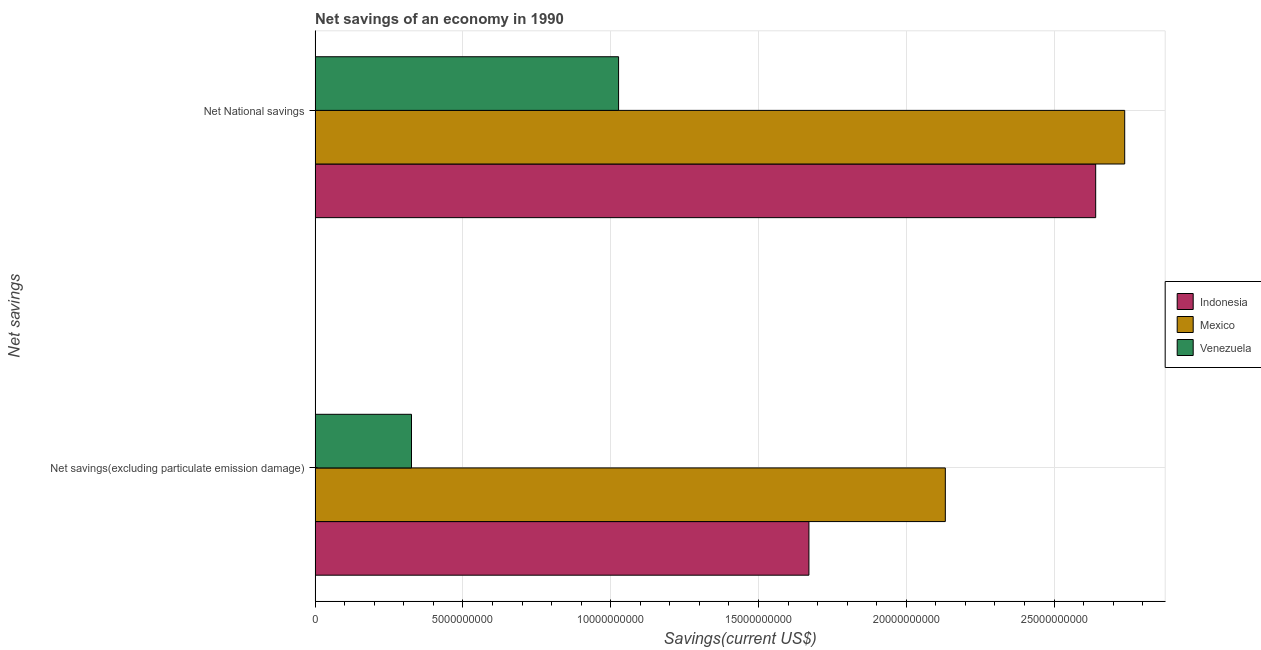How many bars are there on the 2nd tick from the top?
Offer a very short reply. 3. What is the label of the 2nd group of bars from the top?
Provide a short and direct response. Net savings(excluding particulate emission damage). What is the net savings(excluding particulate emission damage) in Mexico?
Provide a succinct answer. 2.13e+1. Across all countries, what is the maximum net national savings?
Your response must be concise. 2.74e+1. Across all countries, what is the minimum net national savings?
Provide a short and direct response. 1.03e+1. In which country was the net national savings maximum?
Your response must be concise. Mexico. In which country was the net savings(excluding particulate emission damage) minimum?
Provide a short and direct response. Venezuela. What is the total net national savings in the graph?
Offer a very short reply. 6.41e+1. What is the difference between the net savings(excluding particulate emission damage) in Venezuela and that in Indonesia?
Offer a terse response. -1.34e+1. What is the difference between the net national savings in Venezuela and the net savings(excluding particulate emission damage) in Mexico?
Your response must be concise. -1.11e+1. What is the average net national savings per country?
Offer a very short reply. 2.14e+1. What is the difference between the net savings(excluding particulate emission damage) and net national savings in Mexico?
Give a very brief answer. -6.07e+09. In how many countries, is the net national savings greater than 22000000000 US$?
Your answer should be compact. 2. What is the ratio of the net savings(excluding particulate emission damage) in Venezuela to that in Mexico?
Your answer should be compact. 0.15. Is the net savings(excluding particulate emission damage) in Mexico less than that in Venezuela?
Your answer should be compact. No. In how many countries, is the net savings(excluding particulate emission damage) greater than the average net savings(excluding particulate emission damage) taken over all countries?
Your answer should be very brief. 2. What does the 3rd bar from the bottom in Net savings(excluding particulate emission damage) represents?
Make the answer very short. Venezuela. How many bars are there?
Provide a short and direct response. 6. How many countries are there in the graph?
Give a very brief answer. 3. Where does the legend appear in the graph?
Your answer should be compact. Center right. What is the title of the graph?
Keep it short and to the point. Net savings of an economy in 1990. What is the label or title of the X-axis?
Provide a succinct answer. Savings(current US$). What is the label or title of the Y-axis?
Your answer should be compact. Net savings. What is the Savings(current US$) in Indonesia in Net savings(excluding particulate emission damage)?
Your response must be concise. 1.67e+1. What is the Savings(current US$) in Mexico in Net savings(excluding particulate emission damage)?
Your response must be concise. 2.13e+1. What is the Savings(current US$) of Venezuela in Net savings(excluding particulate emission damage)?
Give a very brief answer. 3.26e+09. What is the Savings(current US$) of Indonesia in Net National savings?
Give a very brief answer. 2.64e+1. What is the Savings(current US$) in Mexico in Net National savings?
Give a very brief answer. 2.74e+1. What is the Savings(current US$) of Venezuela in Net National savings?
Offer a very short reply. 1.03e+1. Across all Net savings, what is the maximum Savings(current US$) in Indonesia?
Offer a very short reply. 2.64e+1. Across all Net savings, what is the maximum Savings(current US$) in Mexico?
Your answer should be compact. 2.74e+1. Across all Net savings, what is the maximum Savings(current US$) of Venezuela?
Keep it short and to the point. 1.03e+1. Across all Net savings, what is the minimum Savings(current US$) of Indonesia?
Ensure brevity in your answer.  1.67e+1. Across all Net savings, what is the minimum Savings(current US$) of Mexico?
Provide a succinct answer. 2.13e+1. Across all Net savings, what is the minimum Savings(current US$) in Venezuela?
Make the answer very short. 3.26e+09. What is the total Savings(current US$) in Indonesia in the graph?
Provide a short and direct response. 4.31e+1. What is the total Savings(current US$) of Mexico in the graph?
Offer a very short reply. 4.87e+1. What is the total Savings(current US$) in Venezuela in the graph?
Make the answer very short. 1.35e+1. What is the difference between the Savings(current US$) of Indonesia in Net savings(excluding particulate emission damage) and that in Net National savings?
Your answer should be very brief. -9.70e+09. What is the difference between the Savings(current US$) of Mexico in Net savings(excluding particulate emission damage) and that in Net National savings?
Provide a short and direct response. -6.07e+09. What is the difference between the Savings(current US$) in Venezuela in Net savings(excluding particulate emission damage) and that in Net National savings?
Offer a very short reply. -7.01e+09. What is the difference between the Savings(current US$) in Indonesia in Net savings(excluding particulate emission damage) and the Savings(current US$) in Mexico in Net National savings?
Ensure brevity in your answer.  -1.07e+1. What is the difference between the Savings(current US$) in Indonesia in Net savings(excluding particulate emission damage) and the Savings(current US$) in Venezuela in Net National savings?
Provide a short and direct response. 6.44e+09. What is the difference between the Savings(current US$) in Mexico in Net savings(excluding particulate emission damage) and the Savings(current US$) in Venezuela in Net National savings?
Provide a short and direct response. 1.11e+1. What is the average Savings(current US$) of Indonesia per Net savings?
Your response must be concise. 2.16e+1. What is the average Savings(current US$) of Mexico per Net savings?
Your response must be concise. 2.44e+1. What is the average Savings(current US$) in Venezuela per Net savings?
Your response must be concise. 6.76e+09. What is the difference between the Savings(current US$) of Indonesia and Savings(current US$) of Mexico in Net savings(excluding particulate emission damage)?
Provide a succinct answer. -4.62e+09. What is the difference between the Savings(current US$) of Indonesia and Savings(current US$) of Venezuela in Net savings(excluding particulate emission damage)?
Give a very brief answer. 1.34e+1. What is the difference between the Savings(current US$) in Mexico and Savings(current US$) in Venezuela in Net savings(excluding particulate emission damage)?
Your response must be concise. 1.81e+1. What is the difference between the Savings(current US$) in Indonesia and Savings(current US$) in Mexico in Net National savings?
Ensure brevity in your answer.  -9.81e+08. What is the difference between the Savings(current US$) of Indonesia and Savings(current US$) of Venezuela in Net National savings?
Ensure brevity in your answer.  1.61e+1. What is the difference between the Savings(current US$) of Mexico and Savings(current US$) of Venezuela in Net National savings?
Your response must be concise. 1.71e+1. What is the ratio of the Savings(current US$) in Indonesia in Net savings(excluding particulate emission damage) to that in Net National savings?
Give a very brief answer. 0.63. What is the ratio of the Savings(current US$) in Mexico in Net savings(excluding particulate emission damage) to that in Net National savings?
Offer a very short reply. 0.78. What is the ratio of the Savings(current US$) of Venezuela in Net savings(excluding particulate emission damage) to that in Net National savings?
Your response must be concise. 0.32. What is the difference between the highest and the second highest Savings(current US$) in Indonesia?
Provide a short and direct response. 9.70e+09. What is the difference between the highest and the second highest Savings(current US$) of Mexico?
Provide a succinct answer. 6.07e+09. What is the difference between the highest and the second highest Savings(current US$) in Venezuela?
Your answer should be very brief. 7.01e+09. What is the difference between the highest and the lowest Savings(current US$) of Indonesia?
Keep it short and to the point. 9.70e+09. What is the difference between the highest and the lowest Savings(current US$) of Mexico?
Offer a very short reply. 6.07e+09. What is the difference between the highest and the lowest Savings(current US$) in Venezuela?
Offer a very short reply. 7.01e+09. 